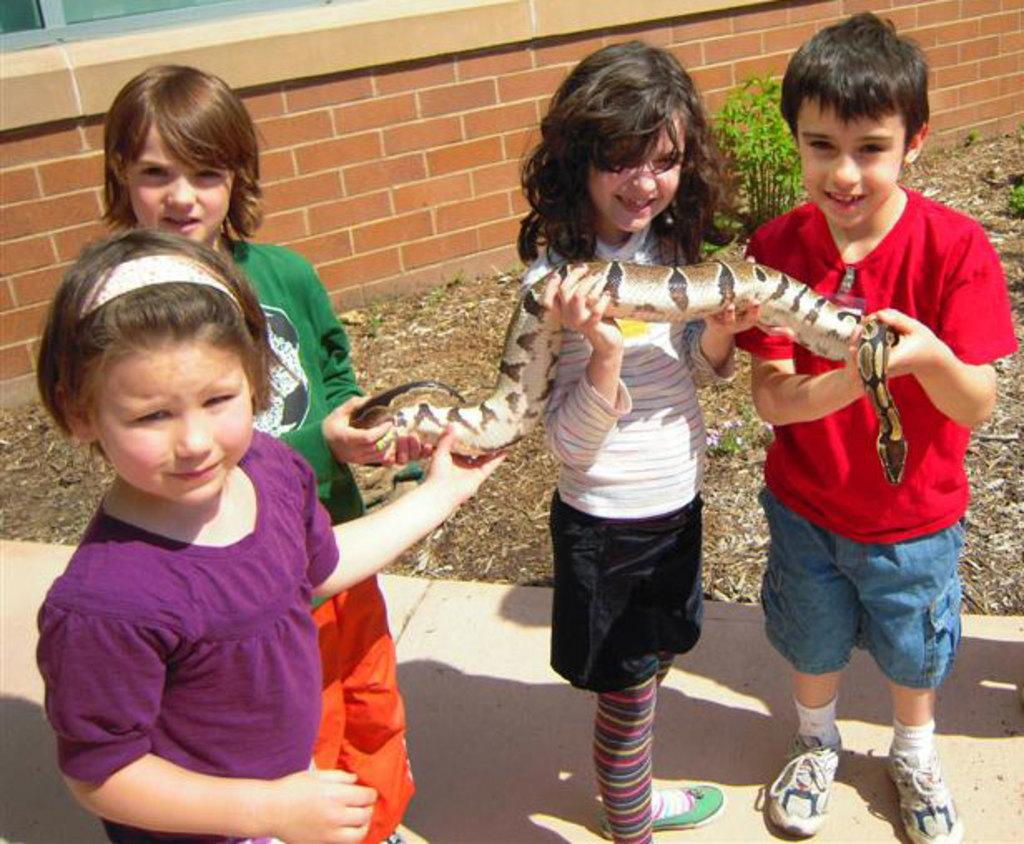How many kids are present in the image? There are four kids in the image. What are the kids doing in the image? The kids are playing with a snake. What can be seen in the background of the image? There is a red color brick wall in the background of the image. What type of sweater is the hill wearing in the image? There is no hill or sweater present in the image; it features four kids playing with a snake. 